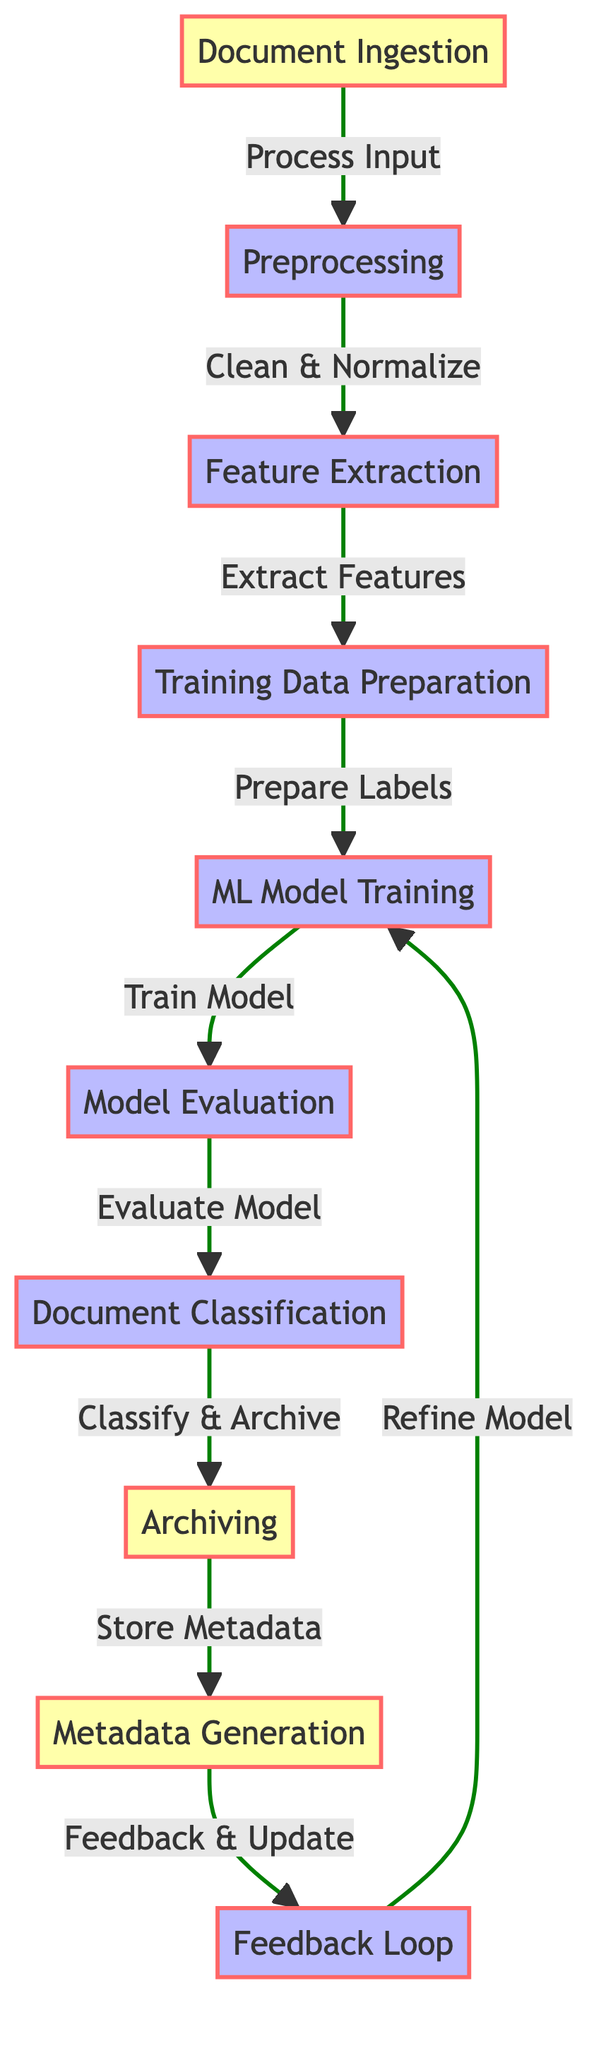What is the first step in the workflow? The first step in the workflow, as indicated in the diagram, is "Document Ingestion" which starts the process of handling new documents.
Answer: Document Ingestion How many processes are involved in this workflow? Counting the nodes classified as processes, there are six processes, which are: Preprocessing, Feature Extraction, Training Data Preparation, ML Model Training, Model Evaluation, and Document Classification.
Answer: Six What type of data is generated after Document Classification? After Document Classification, the data generated is "Archiving", indicating that classified documents are subsequently archived.
Answer: Archiving Which step follows Model Evaluation in the workflow? According to the flow of the diagram, the step that follows Model Evaluation is "Document Classification," where the trained model is used to classify documents.
Answer: Document Classification What is generated after archiving the documents? Following the archiving process, "Metadata Generation" occurs, where metadata related to the classified documents is created.
Answer: Metadata Generation How is the model refined in the workflow? The model is refined by utilizing the "Feedback Loop," which provides feedback and updates that allow for continuous improvement of the model.
Answer: Feedback Loop What is the relationship between Feature Extraction and Training Data Preparation? Feature Extraction feeds into Training Data Preparation; after the features are extracted, they are used to prepare the data for training the model.
Answer: Feeds into What happens to the metadata after it is generated? After the metadata is generated, it is "Stored," indicating that the information is preserved for future reference or use.
Answer: Stored What is the overall purpose of the entire workflow? The overall purpose of the workflow is to utilize machine learning algorithms for classifying and archiving documents efficiently.
Answer: Classifying and archiving documents 